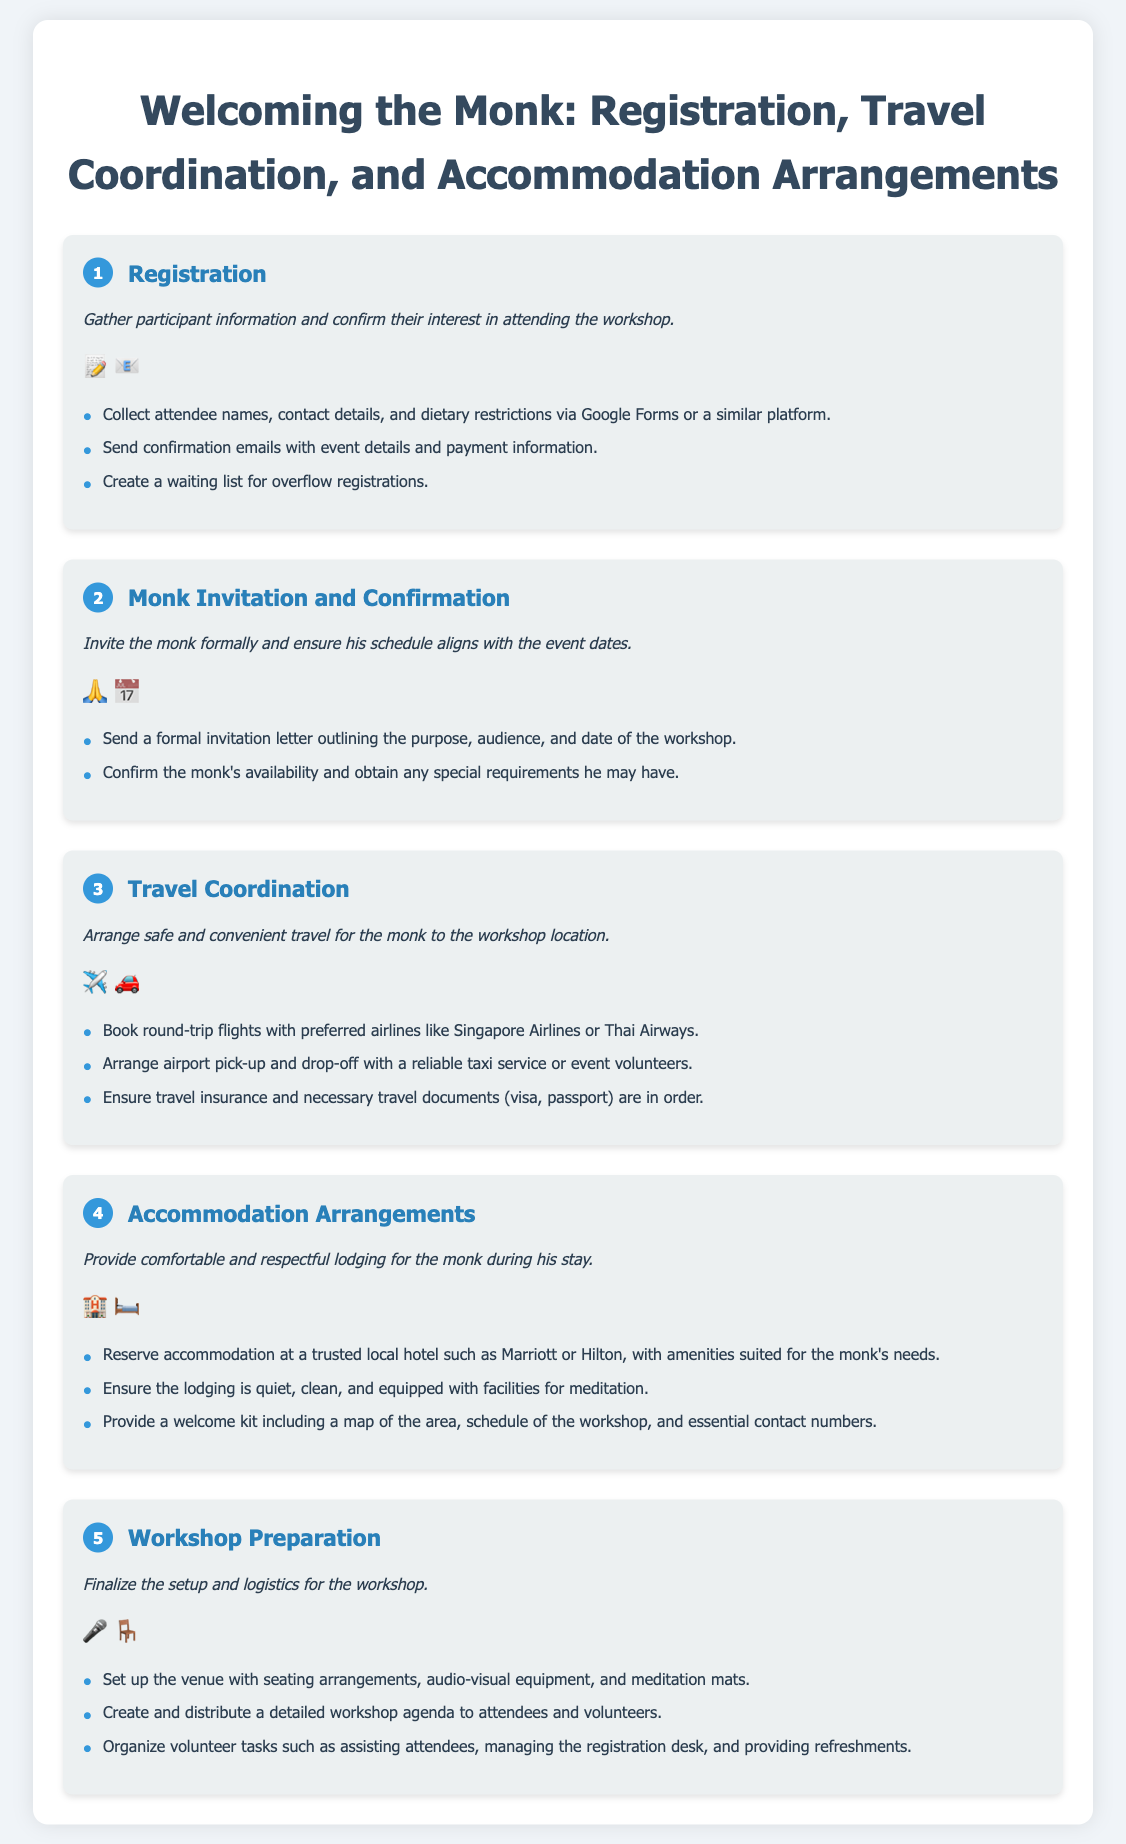What is the first step in the process? The first step in the process is titled "Registration," as indicated in the document.
Answer: Registration How many steps are there in total? The infographic outlines five distinct steps involved in the process.
Answer: Five What are the two icons representing the Travel Coordination step? The icons for Travel Coordination are an airplane and a car, as shown in the document.
Answer: Airplane and car What is included in the welcome kit for the monk? The welcome kit includes a map of the area, schedule of the workshop, and essential contact numbers, according to the details provided.
Answer: Map, schedule, contact numbers What must be confirmed with the monk during the invitation process? It is necessary to confirm the monk's availability and any special requirements he may have during the invitation process.
Answer: Availability and special requirements Which local hotel is mentioned for accommodation arrangements? The document mentions Marriott or Hilton as trusted local hotel options for accommodation.
Answer: Marriott or Hilton What is the purpose of the "Workshop Preparation" step? The Workshop Preparation step is to finalize the setup and logistics for the workshop, as described in the step title.
Answer: Finalize setup and logistics What is one requirement for the accommodation provided to the monk? One requirement for the monk's accommodation is that it should be quiet, clean, and equipped with meditation facilities.
Answer: Quiet, clean, meditation facilities 